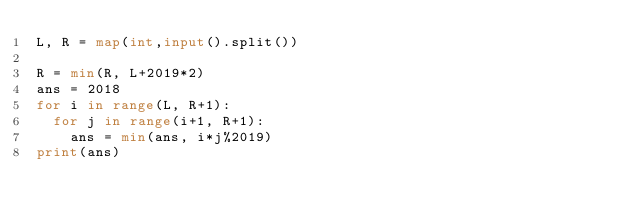Convert code to text. <code><loc_0><loc_0><loc_500><loc_500><_Python_>L, R = map(int,input().split())

R = min(R, L+2019*2)
ans = 2018
for i in range(L, R+1):
  for j in range(i+1, R+1):
    ans = min(ans, i*j%2019)
print(ans)</code> 